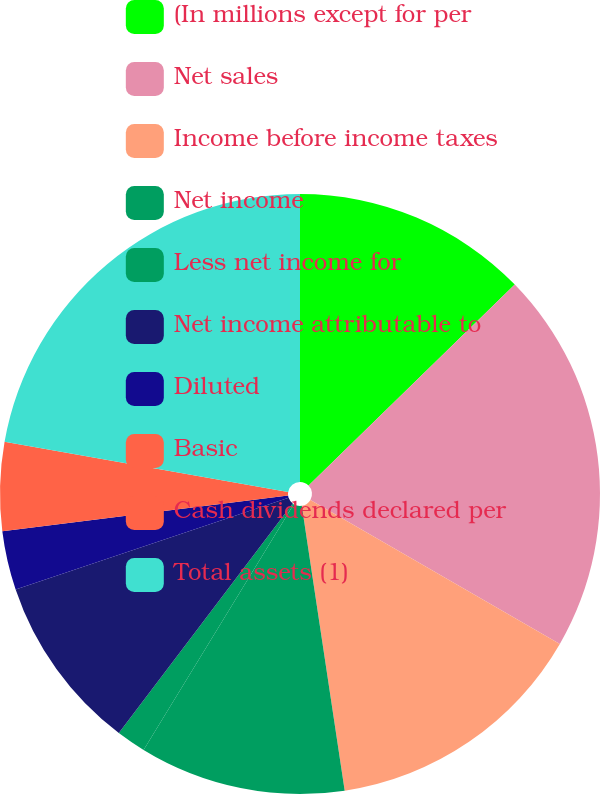Convert chart. <chart><loc_0><loc_0><loc_500><loc_500><pie_chart><fcel>(In millions except for per<fcel>Net sales<fcel>Income before income taxes<fcel>Net income<fcel>Less net income for<fcel>Net income attributable to<fcel>Diluted<fcel>Basic<fcel>Cash dividends declared per<fcel>Total assets (1)<nl><fcel>12.7%<fcel>20.63%<fcel>14.29%<fcel>11.11%<fcel>1.59%<fcel>9.52%<fcel>3.18%<fcel>4.76%<fcel>0.0%<fcel>22.22%<nl></chart> 